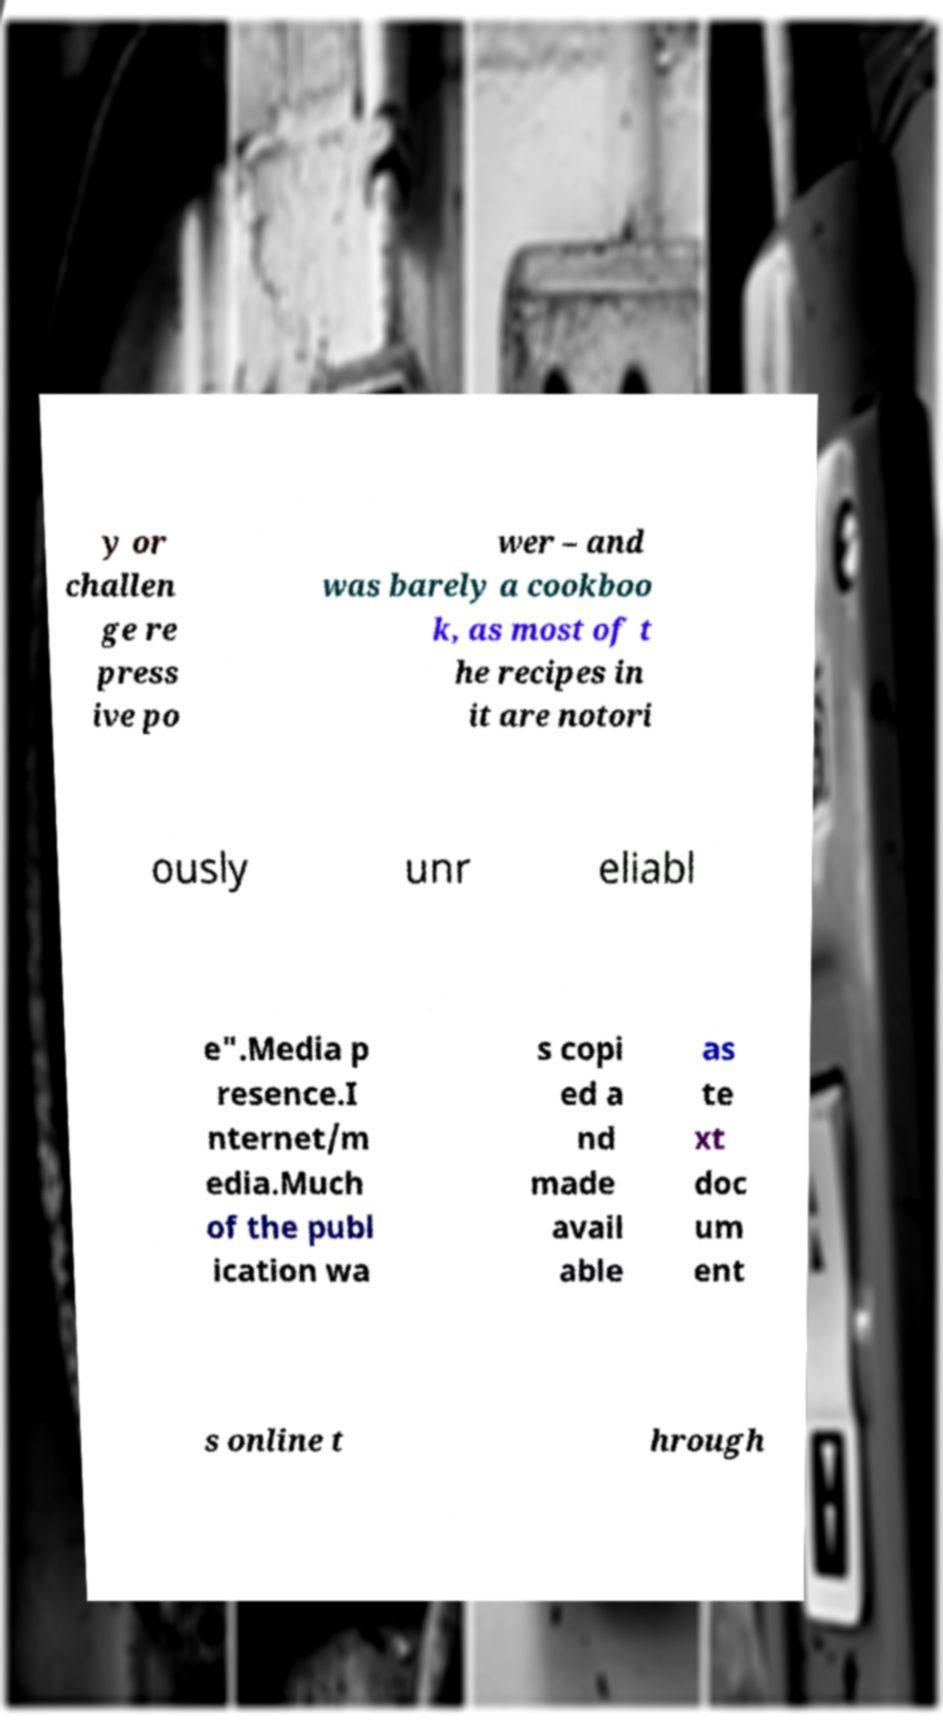Could you assist in decoding the text presented in this image and type it out clearly? y or challen ge re press ive po wer – and was barely a cookboo k, as most of t he recipes in it are notori ously unr eliabl e".Media p resence.I nternet/m edia.Much of the publ ication wa s copi ed a nd made avail able as te xt doc um ent s online t hrough 